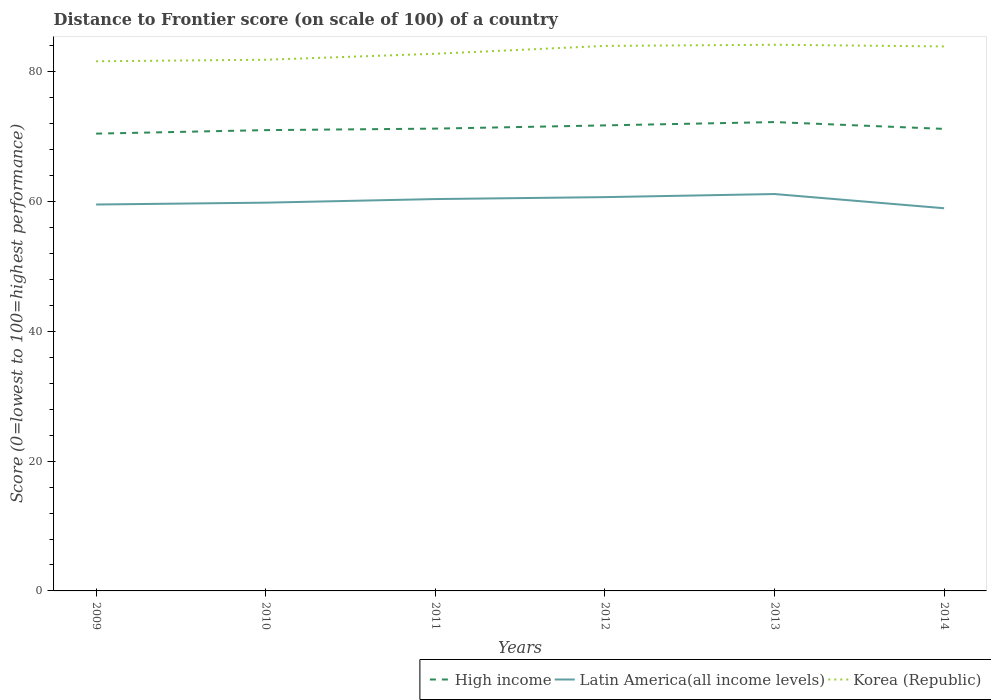Does the line corresponding to High income intersect with the line corresponding to Korea (Republic)?
Provide a succinct answer. No. Is the number of lines equal to the number of legend labels?
Your response must be concise. Yes. Across all years, what is the maximum distance to frontier score of in High income?
Your response must be concise. 70.47. In which year was the distance to frontier score of in Korea (Republic) maximum?
Ensure brevity in your answer.  2009. What is the total distance to frontier score of in Latin America(all income levels) in the graph?
Your answer should be compact. -0.48. What is the difference between the highest and the second highest distance to frontier score of in Latin America(all income levels)?
Provide a short and direct response. 2.19. How many lines are there?
Your answer should be compact. 3. What is the difference between two consecutive major ticks on the Y-axis?
Your answer should be very brief. 20. Does the graph contain any zero values?
Your answer should be compact. No. Does the graph contain grids?
Your answer should be compact. No. Where does the legend appear in the graph?
Your answer should be compact. Bottom right. How many legend labels are there?
Your answer should be compact. 3. What is the title of the graph?
Make the answer very short. Distance to Frontier score (on scale of 100) of a country. What is the label or title of the X-axis?
Provide a short and direct response. Years. What is the label or title of the Y-axis?
Offer a very short reply. Score (0=lowest to 100=highest performance). What is the Score (0=lowest to 100=highest performance) of High income in 2009?
Provide a succinct answer. 70.47. What is the Score (0=lowest to 100=highest performance) of Latin America(all income levels) in 2009?
Provide a short and direct response. 59.55. What is the Score (0=lowest to 100=highest performance) of Korea (Republic) in 2009?
Offer a terse response. 81.62. What is the Score (0=lowest to 100=highest performance) in High income in 2010?
Provide a succinct answer. 71.01. What is the Score (0=lowest to 100=highest performance) in Latin America(all income levels) in 2010?
Provide a succinct answer. 59.83. What is the Score (0=lowest to 100=highest performance) in Korea (Republic) in 2010?
Your response must be concise. 81.86. What is the Score (0=lowest to 100=highest performance) in High income in 2011?
Ensure brevity in your answer.  71.24. What is the Score (0=lowest to 100=highest performance) of Latin America(all income levels) in 2011?
Your answer should be compact. 60.39. What is the Score (0=lowest to 100=highest performance) in Korea (Republic) in 2011?
Keep it short and to the point. 82.78. What is the Score (0=lowest to 100=highest performance) of High income in 2012?
Provide a short and direct response. 71.74. What is the Score (0=lowest to 100=highest performance) in Latin America(all income levels) in 2012?
Make the answer very short. 60.69. What is the Score (0=lowest to 100=highest performance) in Korea (Republic) in 2012?
Ensure brevity in your answer.  83.99. What is the Score (0=lowest to 100=highest performance) in High income in 2013?
Keep it short and to the point. 72.25. What is the Score (0=lowest to 100=highest performance) of Latin America(all income levels) in 2013?
Make the answer very short. 61.16. What is the Score (0=lowest to 100=highest performance) in Korea (Republic) in 2013?
Your answer should be compact. 84.17. What is the Score (0=lowest to 100=highest performance) of High income in 2014?
Offer a very short reply. 71.2. What is the Score (0=lowest to 100=highest performance) in Latin America(all income levels) in 2014?
Provide a short and direct response. 58.97. What is the Score (0=lowest to 100=highest performance) in Korea (Republic) in 2014?
Make the answer very short. 83.91. Across all years, what is the maximum Score (0=lowest to 100=highest performance) in High income?
Ensure brevity in your answer.  72.25. Across all years, what is the maximum Score (0=lowest to 100=highest performance) of Latin America(all income levels)?
Give a very brief answer. 61.16. Across all years, what is the maximum Score (0=lowest to 100=highest performance) in Korea (Republic)?
Offer a terse response. 84.17. Across all years, what is the minimum Score (0=lowest to 100=highest performance) in High income?
Your answer should be very brief. 70.47. Across all years, what is the minimum Score (0=lowest to 100=highest performance) in Latin America(all income levels)?
Make the answer very short. 58.97. Across all years, what is the minimum Score (0=lowest to 100=highest performance) of Korea (Republic)?
Provide a short and direct response. 81.62. What is the total Score (0=lowest to 100=highest performance) of High income in the graph?
Your answer should be very brief. 427.93. What is the total Score (0=lowest to 100=highest performance) of Latin America(all income levels) in the graph?
Your response must be concise. 360.6. What is the total Score (0=lowest to 100=highest performance) in Korea (Republic) in the graph?
Offer a very short reply. 498.33. What is the difference between the Score (0=lowest to 100=highest performance) in High income in 2009 and that in 2010?
Keep it short and to the point. -0.54. What is the difference between the Score (0=lowest to 100=highest performance) in Latin America(all income levels) in 2009 and that in 2010?
Your answer should be very brief. -0.28. What is the difference between the Score (0=lowest to 100=highest performance) in Korea (Republic) in 2009 and that in 2010?
Offer a very short reply. -0.24. What is the difference between the Score (0=lowest to 100=highest performance) of High income in 2009 and that in 2011?
Give a very brief answer. -0.77. What is the difference between the Score (0=lowest to 100=highest performance) in Latin America(all income levels) in 2009 and that in 2011?
Provide a succinct answer. -0.84. What is the difference between the Score (0=lowest to 100=highest performance) in Korea (Republic) in 2009 and that in 2011?
Offer a terse response. -1.16. What is the difference between the Score (0=lowest to 100=highest performance) in High income in 2009 and that in 2012?
Your response must be concise. -1.27. What is the difference between the Score (0=lowest to 100=highest performance) in Latin America(all income levels) in 2009 and that in 2012?
Your response must be concise. -1.14. What is the difference between the Score (0=lowest to 100=highest performance) of Korea (Republic) in 2009 and that in 2012?
Your response must be concise. -2.37. What is the difference between the Score (0=lowest to 100=highest performance) of High income in 2009 and that in 2013?
Offer a terse response. -1.78. What is the difference between the Score (0=lowest to 100=highest performance) of Latin America(all income levels) in 2009 and that in 2013?
Offer a very short reply. -1.61. What is the difference between the Score (0=lowest to 100=highest performance) of Korea (Republic) in 2009 and that in 2013?
Offer a terse response. -2.55. What is the difference between the Score (0=lowest to 100=highest performance) in High income in 2009 and that in 2014?
Your answer should be compact. -0.73. What is the difference between the Score (0=lowest to 100=highest performance) of Latin America(all income levels) in 2009 and that in 2014?
Your answer should be very brief. 0.57. What is the difference between the Score (0=lowest to 100=highest performance) in Korea (Republic) in 2009 and that in 2014?
Your answer should be very brief. -2.29. What is the difference between the Score (0=lowest to 100=highest performance) in High income in 2010 and that in 2011?
Keep it short and to the point. -0.23. What is the difference between the Score (0=lowest to 100=highest performance) in Latin America(all income levels) in 2010 and that in 2011?
Provide a short and direct response. -0.56. What is the difference between the Score (0=lowest to 100=highest performance) in Korea (Republic) in 2010 and that in 2011?
Make the answer very short. -0.92. What is the difference between the Score (0=lowest to 100=highest performance) of High income in 2010 and that in 2012?
Provide a succinct answer. -0.73. What is the difference between the Score (0=lowest to 100=highest performance) in Latin America(all income levels) in 2010 and that in 2012?
Offer a terse response. -0.85. What is the difference between the Score (0=lowest to 100=highest performance) in Korea (Republic) in 2010 and that in 2012?
Your answer should be compact. -2.13. What is the difference between the Score (0=lowest to 100=highest performance) in High income in 2010 and that in 2013?
Offer a very short reply. -1.24. What is the difference between the Score (0=lowest to 100=highest performance) in Latin America(all income levels) in 2010 and that in 2013?
Offer a very short reply. -1.33. What is the difference between the Score (0=lowest to 100=highest performance) of Korea (Republic) in 2010 and that in 2013?
Your answer should be compact. -2.31. What is the difference between the Score (0=lowest to 100=highest performance) of High income in 2010 and that in 2014?
Your answer should be very brief. -0.19. What is the difference between the Score (0=lowest to 100=highest performance) of Latin America(all income levels) in 2010 and that in 2014?
Offer a very short reply. 0.86. What is the difference between the Score (0=lowest to 100=highest performance) of Korea (Republic) in 2010 and that in 2014?
Provide a short and direct response. -2.05. What is the difference between the Score (0=lowest to 100=highest performance) in High income in 2011 and that in 2012?
Provide a short and direct response. -0.5. What is the difference between the Score (0=lowest to 100=highest performance) in Latin America(all income levels) in 2011 and that in 2012?
Your answer should be very brief. -0.3. What is the difference between the Score (0=lowest to 100=highest performance) in Korea (Republic) in 2011 and that in 2012?
Your answer should be very brief. -1.21. What is the difference between the Score (0=lowest to 100=highest performance) of High income in 2011 and that in 2013?
Your answer should be very brief. -1.01. What is the difference between the Score (0=lowest to 100=highest performance) in Latin America(all income levels) in 2011 and that in 2013?
Your response must be concise. -0.77. What is the difference between the Score (0=lowest to 100=highest performance) in Korea (Republic) in 2011 and that in 2013?
Keep it short and to the point. -1.39. What is the difference between the Score (0=lowest to 100=highest performance) in High income in 2011 and that in 2014?
Provide a short and direct response. 0.04. What is the difference between the Score (0=lowest to 100=highest performance) of Latin America(all income levels) in 2011 and that in 2014?
Your response must be concise. 1.42. What is the difference between the Score (0=lowest to 100=highest performance) in Korea (Republic) in 2011 and that in 2014?
Your answer should be compact. -1.13. What is the difference between the Score (0=lowest to 100=highest performance) of High income in 2012 and that in 2013?
Offer a terse response. -0.51. What is the difference between the Score (0=lowest to 100=highest performance) in Latin America(all income levels) in 2012 and that in 2013?
Your answer should be compact. -0.48. What is the difference between the Score (0=lowest to 100=highest performance) in Korea (Republic) in 2012 and that in 2013?
Offer a terse response. -0.18. What is the difference between the Score (0=lowest to 100=highest performance) of High income in 2012 and that in 2014?
Your response must be concise. 0.54. What is the difference between the Score (0=lowest to 100=highest performance) in Latin America(all income levels) in 2012 and that in 2014?
Your answer should be compact. 1.71. What is the difference between the Score (0=lowest to 100=highest performance) in Korea (Republic) in 2012 and that in 2014?
Ensure brevity in your answer.  0.08. What is the difference between the Score (0=lowest to 100=highest performance) in High income in 2013 and that in 2014?
Ensure brevity in your answer.  1.05. What is the difference between the Score (0=lowest to 100=highest performance) of Latin America(all income levels) in 2013 and that in 2014?
Offer a very short reply. 2.19. What is the difference between the Score (0=lowest to 100=highest performance) in Korea (Republic) in 2013 and that in 2014?
Your answer should be compact. 0.26. What is the difference between the Score (0=lowest to 100=highest performance) in High income in 2009 and the Score (0=lowest to 100=highest performance) in Latin America(all income levels) in 2010?
Offer a very short reply. 10.64. What is the difference between the Score (0=lowest to 100=highest performance) of High income in 2009 and the Score (0=lowest to 100=highest performance) of Korea (Republic) in 2010?
Provide a short and direct response. -11.39. What is the difference between the Score (0=lowest to 100=highest performance) in Latin America(all income levels) in 2009 and the Score (0=lowest to 100=highest performance) in Korea (Republic) in 2010?
Offer a very short reply. -22.31. What is the difference between the Score (0=lowest to 100=highest performance) of High income in 2009 and the Score (0=lowest to 100=highest performance) of Latin America(all income levels) in 2011?
Your response must be concise. 10.08. What is the difference between the Score (0=lowest to 100=highest performance) of High income in 2009 and the Score (0=lowest to 100=highest performance) of Korea (Republic) in 2011?
Offer a terse response. -12.31. What is the difference between the Score (0=lowest to 100=highest performance) of Latin America(all income levels) in 2009 and the Score (0=lowest to 100=highest performance) of Korea (Republic) in 2011?
Your answer should be very brief. -23.23. What is the difference between the Score (0=lowest to 100=highest performance) in High income in 2009 and the Score (0=lowest to 100=highest performance) in Latin America(all income levels) in 2012?
Your answer should be very brief. 9.79. What is the difference between the Score (0=lowest to 100=highest performance) in High income in 2009 and the Score (0=lowest to 100=highest performance) in Korea (Republic) in 2012?
Your answer should be very brief. -13.52. What is the difference between the Score (0=lowest to 100=highest performance) in Latin America(all income levels) in 2009 and the Score (0=lowest to 100=highest performance) in Korea (Republic) in 2012?
Keep it short and to the point. -24.44. What is the difference between the Score (0=lowest to 100=highest performance) of High income in 2009 and the Score (0=lowest to 100=highest performance) of Latin America(all income levels) in 2013?
Make the answer very short. 9.31. What is the difference between the Score (0=lowest to 100=highest performance) of High income in 2009 and the Score (0=lowest to 100=highest performance) of Korea (Republic) in 2013?
Ensure brevity in your answer.  -13.7. What is the difference between the Score (0=lowest to 100=highest performance) of Latin America(all income levels) in 2009 and the Score (0=lowest to 100=highest performance) of Korea (Republic) in 2013?
Ensure brevity in your answer.  -24.62. What is the difference between the Score (0=lowest to 100=highest performance) of High income in 2009 and the Score (0=lowest to 100=highest performance) of Latin America(all income levels) in 2014?
Make the answer very short. 11.5. What is the difference between the Score (0=lowest to 100=highest performance) of High income in 2009 and the Score (0=lowest to 100=highest performance) of Korea (Republic) in 2014?
Ensure brevity in your answer.  -13.44. What is the difference between the Score (0=lowest to 100=highest performance) of Latin America(all income levels) in 2009 and the Score (0=lowest to 100=highest performance) of Korea (Republic) in 2014?
Your answer should be very brief. -24.36. What is the difference between the Score (0=lowest to 100=highest performance) of High income in 2010 and the Score (0=lowest to 100=highest performance) of Latin America(all income levels) in 2011?
Provide a short and direct response. 10.62. What is the difference between the Score (0=lowest to 100=highest performance) of High income in 2010 and the Score (0=lowest to 100=highest performance) of Korea (Republic) in 2011?
Your answer should be very brief. -11.77. What is the difference between the Score (0=lowest to 100=highest performance) of Latin America(all income levels) in 2010 and the Score (0=lowest to 100=highest performance) of Korea (Republic) in 2011?
Your response must be concise. -22.95. What is the difference between the Score (0=lowest to 100=highest performance) of High income in 2010 and the Score (0=lowest to 100=highest performance) of Latin America(all income levels) in 2012?
Your answer should be compact. 10.33. What is the difference between the Score (0=lowest to 100=highest performance) of High income in 2010 and the Score (0=lowest to 100=highest performance) of Korea (Republic) in 2012?
Provide a succinct answer. -12.98. What is the difference between the Score (0=lowest to 100=highest performance) of Latin America(all income levels) in 2010 and the Score (0=lowest to 100=highest performance) of Korea (Republic) in 2012?
Offer a terse response. -24.16. What is the difference between the Score (0=lowest to 100=highest performance) of High income in 2010 and the Score (0=lowest to 100=highest performance) of Latin America(all income levels) in 2013?
Offer a very short reply. 9.85. What is the difference between the Score (0=lowest to 100=highest performance) of High income in 2010 and the Score (0=lowest to 100=highest performance) of Korea (Republic) in 2013?
Your answer should be compact. -13.16. What is the difference between the Score (0=lowest to 100=highest performance) of Latin America(all income levels) in 2010 and the Score (0=lowest to 100=highest performance) of Korea (Republic) in 2013?
Provide a succinct answer. -24.34. What is the difference between the Score (0=lowest to 100=highest performance) of High income in 2010 and the Score (0=lowest to 100=highest performance) of Latin America(all income levels) in 2014?
Your answer should be very brief. 12.04. What is the difference between the Score (0=lowest to 100=highest performance) of High income in 2010 and the Score (0=lowest to 100=highest performance) of Korea (Republic) in 2014?
Make the answer very short. -12.9. What is the difference between the Score (0=lowest to 100=highest performance) in Latin America(all income levels) in 2010 and the Score (0=lowest to 100=highest performance) in Korea (Republic) in 2014?
Make the answer very short. -24.08. What is the difference between the Score (0=lowest to 100=highest performance) in High income in 2011 and the Score (0=lowest to 100=highest performance) in Latin America(all income levels) in 2012?
Provide a succinct answer. 10.56. What is the difference between the Score (0=lowest to 100=highest performance) in High income in 2011 and the Score (0=lowest to 100=highest performance) in Korea (Republic) in 2012?
Your response must be concise. -12.75. What is the difference between the Score (0=lowest to 100=highest performance) of Latin America(all income levels) in 2011 and the Score (0=lowest to 100=highest performance) of Korea (Republic) in 2012?
Offer a very short reply. -23.6. What is the difference between the Score (0=lowest to 100=highest performance) of High income in 2011 and the Score (0=lowest to 100=highest performance) of Latin America(all income levels) in 2013?
Provide a short and direct response. 10.08. What is the difference between the Score (0=lowest to 100=highest performance) of High income in 2011 and the Score (0=lowest to 100=highest performance) of Korea (Republic) in 2013?
Offer a very short reply. -12.93. What is the difference between the Score (0=lowest to 100=highest performance) in Latin America(all income levels) in 2011 and the Score (0=lowest to 100=highest performance) in Korea (Republic) in 2013?
Keep it short and to the point. -23.78. What is the difference between the Score (0=lowest to 100=highest performance) in High income in 2011 and the Score (0=lowest to 100=highest performance) in Latin America(all income levels) in 2014?
Your answer should be compact. 12.27. What is the difference between the Score (0=lowest to 100=highest performance) of High income in 2011 and the Score (0=lowest to 100=highest performance) of Korea (Republic) in 2014?
Your response must be concise. -12.67. What is the difference between the Score (0=lowest to 100=highest performance) of Latin America(all income levels) in 2011 and the Score (0=lowest to 100=highest performance) of Korea (Republic) in 2014?
Ensure brevity in your answer.  -23.52. What is the difference between the Score (0=lowest to 100=highest performance) in High income in 2012 and the Score (0=lowest to 100=highest performance) in Latin America(all income levels) in 2013?
Give a very brief answer. 10.58. What is the difference between the Score (0=lowest to 100=highest performance) of High income in 2012 and the Score (0=lowest to 100=highest performance) of Korea (Republic) in 2013?
Offer a terse response. -12.43. What is the difference between the Score (0=lowest to 100=highest performance) in Latin America(all income levels) in 2012 and the Score (0=lowest to 100=highest performance) in Korea (Republic) in 2013?
Provide a short and direct response. -23.48. What is the difference between the Score (0=lowest to 100=highest performance) in High income in 2012 and the Score (0=lowest to 100=highest performance) in Latin America(all income levels) in 2014?
Your response must be concise. 12.77. What is the difference between the Score (0=lowest to 100=highest performance) of High income in 2012 and the Score (0=lowest to 100=highest performance) of Korea (Republic) in 2014?
Ensure brevity in your answer.  -12.17. What is the difference between the Score (0=lowest to 100=highest performance) in Latin America(all income levels) in 2012 and the Score (0=lowest to 100=highest performance) in Korea (Republic) in 2014?
Keep it short and to the point. -23.22. What is the difference between the Score (0=lowest to 100=highest performance) of High income in 2013 and the Score (0=lowest to 100=highest performance) of Latin America(all income levels) in 2014?
Provide a succinct answer. 13.28. What is the difference between the Score (0=lowest to 100=highest performance) in High income in 2013 and the Score (0=lowest to 100=highest performance) in Korea (Republic) in 2014?
Ensure brevity in your answer.  -11.66. What is the difference between the Score (0=lowest to 100=highest performance) in Latin America(all income levels) in 2013 and the Score (0=lowest to 100=highest performance) in Korea (Republic) in 2014?
Your answer should be very brief. -22.75. What is the average Score (0=lowest to 100=highest performance) of High income per year?
Give a very brief answer. 71.32. What is the average Score (0=lowest to 100=highest performance) in Latin America(all income levels) per year?
Give a very brief answer. 60.1. What is the average Score (0=lowest to 100=highest performance) in Korea (Republic) per year?
Give a very brief answer. 83.06. In the year 2009, what is the difference between the Score (0=lowest to 100=highest performance) of High income and Score (0=lowest to 100=highest performance) of Latin America(all income levels)?
Your answer should be compact. 10.92. In the year 2009, what is the difference between the Score (0=lowest to 100=highest performance) in High income and Score (0=lowest to 100=highest performance) in Korea (Republic)?
Offer a terse response. -11.15. In the year 2009, what is the difference between the Score (0=lowest to 100=highest performance) of Latin America(all income levels) and Score (0=lowest to 100=highest performance) of Korea (Republic)?
Your response must be concise. -22.07. In the year 2010, what is the difference between the Score (0=lowest to 100=highest performance) of High income and Score (0=lowest to 100=highest performance) of Latin America(all income levels)?
Make the answer very short. 11.18. In the year 2010, what is the difference between the Score (0=lowest to 100=highest performance) in High income and Score (0=lowest to 100=highest performance) in Korea (Republic)?
Your response must be concise. -10.85. In the year 2010, what is the difference between the Score (0=lowest to 100=highest performance) in Latin America(all income levels) and Score (0=lowest to 100=highest performance) in Korea (Republic)?
Keep it short and to the point. -22.03. In the year 2011, what is the difference between the Score (0=lowest to 100=highest performance) in High income and Score (0=lowest to 100=highest performance) in Latin America(all income levels)?
Your response must be concise. 10.85. In the year 2011, what is the difference between the Score (0=lowest to 100=highest performance) of High income and Score (0=lowest to 100=highest performance) of Korea (Republic)?
Ensure brevity in your answer.  -11.54. In the year 2011, what is the difference between the Score (0=lowest to 100=highest performance) in Latin America(all income levels) and Score (0=lowest to 100=highest performance) in Korea (Republic)?
Provide a succinct answer. -22.39. In the year 2012, what is the difference between the Score (0=lowest to 100=highest performance) of High income and Score (0=lowest to 100=highest performance) of Latin America(all income levels)?
Provide a short and direct response. 11.06. In the year 2012, what is the difference between the Score (0=lowest to 100=highest performance) in High income and Score (0=lowest to 100=highest performance) in Korea (Republic)?
Offer a very short reply. -12.25. In the year 2012, what is the difference between the Score (0=lowest to 100=highest performance) of Latin America(all income levels) and Score (0=lowest to 100=highest performance) of Korea (Republic)?
Make the answer very short. -23.3. In the year 2013, what is the difference between the Score (0=lowest to 100=highest performance) of High income and Score (0=lowest to 100=highest performance) of Latin America(all income levels)?
Give a very brief answer. 11.09. In the year 2013, what is the difference between the Score (0=lowest to 100=highest performance) in High income and Score (0=lowest to 100=highest performance) in Korea (Republic)?
Make the answer very short. -11.92. In the year 2013, what is the difference between the Score (0=lowest to 100=highest performance) in Latin America(all income levels) and Score (0=lowest to 100=highest performance) in Korea (Republic)?
Provide a short and direct response. -23.01. In the year 2014, what is the difference between the Score (0=lowest to 100=highest performance) in High income and Score (0=lowest to 100=highest performance) in Latin America(all income levels)?
Keep it short and to the point. 12.23. In the year 2014, what is the difference between the Score (0=lowest to 100=highest performance) in High income and Score (0=lowest to 100=highest performance) in Korea (Republic)?
Keep it short and to the point. -12.71. In the year 2014, what is the difference between the Score (0=lowest to 100=highest performance) of Latin America(all income levels) and Score (0=lowest to 100=highest performance) of Korea (Republic)?
Provide a short and direct response. -24.94. What is the ratio of the Score (0=lowest to 100=highest performance) in High income in 2009 to that in 2010?
Keep it short and to the point. 0.99. What is the ratio of the Score (0=lowest to 100=highest performance) in Latin America(all income levels) in 2009 to that in 2010?
Make the answer very short. 1. What is the ratio of the Score (0=lowest to 100=highest performance) in Korea (Republic) in 2009 to that in 2010?
Offer a terse response. 1. What is the ratio of the Score (0=lowest to 100=highest performance) in Latin America(all income levels) in 2009 to that in 2011?
Your response must be concise. 0.99. What is the ratio of the Score (0=lowest to 100=highest performance) of Korea (Republic) in 2009 to that in 2011?
Offer a terse response. 0.99. What is the ratio of the Score (0=lowest to 100=highest performance) of High income in 2009 to that in 2012?
Give a very brief answer. 0.98. What is the ratio of the Score (0=lowest to 100=highest performance) of Latin America(all income levels) in 2009 to that in 2012?
Ensure brevity in your answer.  0.98. What is the ratio of the Score (0=lowest to 100=highest performance) in Korea (Republic) in 2009 to that in 2012?
Your answer should be compact. 0.97. What is the ratio of the Score (0=lowest to 100=highest performance) of High income in 2009 to that in 2013?
Keep it short and to the point. 0.98. What is the ratio of the Score (0=lowest to 100=highest performance) in Latin America(all income levels) in 2009 to that in 2013?
Your answer should be very brief. 0.97. What is the ratio of the Score (0=lowest to 100=highest performance) of Korea (Republic) in 2009 to that in 2013?
Give a very brief answer. 0.97. What is the ratio of the Score (0=lowest to 100=highest performance) in High income in 2009 to that in 2014?
Your response must be concise. 0.99. What is the ratio of the Score (0=lowest to 100=highest performance) in Latin America(all income levels) in 2009 to that in 2014?
Your response must be concise. 1.01. What is the ratio of the Score (0=lowest to 100=highest performance) of Korea (Republic) in 2009 to that in 2014?
Give a very brief answer. 0.97. What is the ratio of the Score (0=lowest to 100=highest performance) of Latin America(all income levels) in 2010 to that in 2011?
Provide a short and direct response. 0.99. What is the ratio of the Score (0=lowest to 100=highest performance) in Korea (Republic) in 2010 to that in 2011?
Provide a succinct answer. 0.99. What is the ratio of the Score (0=lowest to 100=highest performance) in Korea (Republic) in 2010 to that in 2012?
Your response must be concise. 0.97. What is the ratio of the Score (0=lowest to 100=highest performance) of High income in 2010 to that in 2013?
Your answer should be compact. 0.98. What is the ratio of the Score (0=lowest to 100=highest performance) in Latin America(all income levels) in 2010 to that in 2013?
Offer a very short reply. 0.98. What is the ratio of the Score (0=lowest to 100=highest performance) in Korea (Republic) in 2010 to that in 2013?
Your answer should be compact. 0.97. What is the ratio of the Score (0=lowest to 100=highest performance) of Latin America(all income levels) in 2010 to that in 2014?
Ensure brevity in your answer.  1.01. What is the ratio of the Score (0=lowest to 100=highest performance) in Korea (Republic) in 2010 to that in 2014?
Ensure brevity in your answer.  0.98. What is the ratio of the Score (0=lowest to 100=highest performance) of High income in 2011 to that in 2012?
Keep it short and to the point. 0.99. What is the ratio of the Score (0=lowest to 100=highest performance) in Korea (Republic) in 2011 to that in 2012?
Provide a succinct answer. 0.99. What is the ratio of the Score (0=lowest to 100=highest performance) of Latin America(all income levels) in 2011 to that in 2013?
Give a very brief answer. 0.99. What is the ratio of the Score (0=lowest to 100=highest performance) of Korea (Republic) in 2011 to that in 2013?
Provide a succinct answer. 0.98. What is the ratio of the Score (0=lowest to 100=highest performance) in High income in 2011 to that in 2014?
Your response must be concise. 1. What is the ratio of the Score (0=lowest to 100=highest performance) of Korea (Republic) in 2011 to that in 2014?
Make the answer very short. 0.99. What is the ratio of the Score (0=lowest to 100=highest performance) of High income in 2012 to that in 2014?
Ensure brevity in your answer.  1.01. What is the ratio of the Score (0=lowest to 100=highest performance) of Korea (Republic) in 2012 to that in 2014?
Give a very brief answer. 1. What is the ratio of the Score (0=lowest to 100=highest performance) in High income in 2013 to that in 2014?
Offer a very short reply. 1.01. What is the ratio of the Score (0=lowest to 100=highest performance) of Latin America(all income levels) in 2013 to that in 2014?
Your response must be concise. 1.04. What is the ratio of the Score (0=lowest to 100=highest performance) of Korea (Republic) in 2013 to that in 2014?
Provide a succinct answer. 1. What is the difference between the highest and the second highest Score (0=lowest to 100=highest performance) in High income?
Give a very brief answer. 0.51. What is the difference between the highest and the second highest Score (0=lowest to 100=highest performance) of Latin America(all income levels)?
Keep it short and to the point. 0.48. What is the difference between the highest and the second highest Score (0=lowest to 100=highest performance) in Korea (Republic)?
Offer a terse response. 0.18. What is the difference between the highest and the lowest Score (0=lowest to 100=highest performance) of High income?
Provide a short and direct response. 1.78. What is the difference between the highest and the lowest Score (0=lowest to 100=highest performance) in Latin America(all income levels)?
Make the answer very short. 2.19. What is the difference between the highest and the lowest Score (0=lowest to 100=highest performance) in Korea (Republic)?
Offer a terse response. 2.55. 